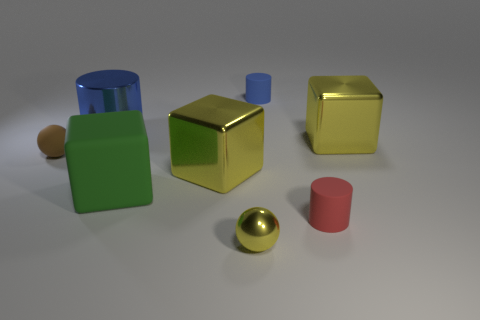How big is the matte thing that is behind the large green object and in front of the large metal cylinder?
Provide a succinct answer. Small. There is a rubber thing that is left of the small yellow thing and in front of the small brown matte thing; what is its shape?
Your answer should be compact. Cube. Is there a red rubber cylinder that is behind the large shiny block in front of the ball that is to the left of the small yellow ball?
Provide a short and direct response. No. What number of things are either blue cylinders that are left of the small blue rubber thing or shiny blocks to the left of the small blue rubber object?
Your answer should be very brief. 2. Do the tiny sphere that is left of the small yellow sphere and the small blue cylinder have the same material?
Provide a succinct answer. Yes. What is the material of the thing that is in front of the blue metallic object and on the left side of the big green cube?
Keep it short and to the point. Rubber. There is a big metal object that is to the right of the yellow metal cube on the left side of the tiny blue thing; what is its color?
Your answer should be compact. Yellow. There is a large blue thing that is the same shape as the red rubber object; what material is it?
Give a very brief answer. Metal. What color is the tiny thing left of the shiny cube to the left of the tiny matte object that is right of the tiny blue matte thing?
Give a very brief answer. Brown. What number of objects are big purple rubber balls or yellow blocks?
Offer a very short reply. 2. 